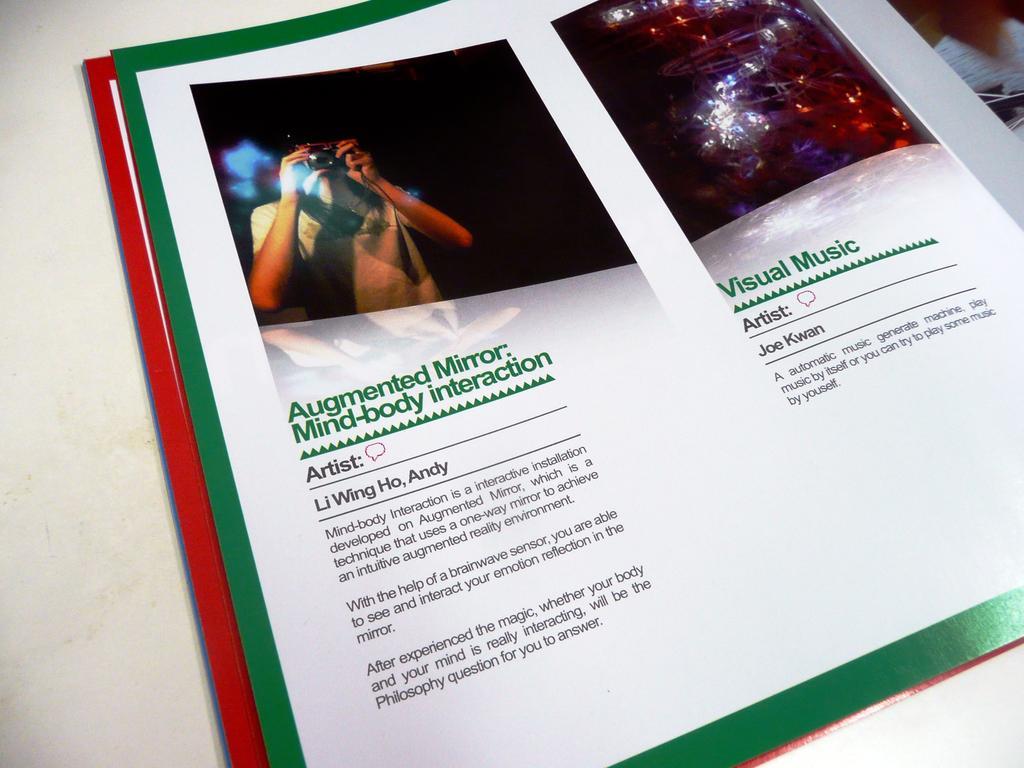In one or two sentences, can you explain what this image depicts? In this image, we can see a magazine. In this magazine, we can see few pictures and information. Here we can see a person is holding a camera. On the left side of the image, we can see white and red colors. Right side top corner, there are few objects. 